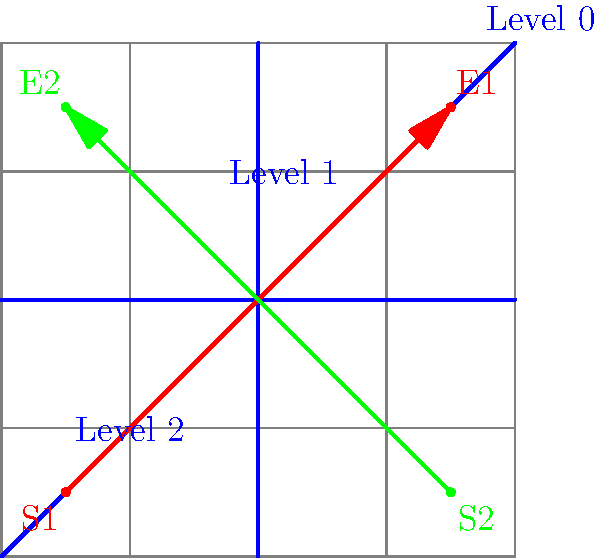In the context of implementing hierarchical pathfinding for a large open-world game map, as shown in the diagram, what is the primary advantage of using this approach over traditional A* pathfinding, and how would you calculate the heuristic cost between two points at different hierarchical levels? To understand the advantages of hierarchical pathfinding and calculate heuristics between different levels, let's break it down step-by-step:

1. Hierarchical Structure:
   The diagram shows a map divided into three levels (0, 1, and 2), with each level representing a different granularity of the game world.

2. Advantage over traditional A*:
   The primary advantage is improved performance for long-distance pathfinding. Instead of searching through every node in the game world, the algorithm can:
   a) First find a path at the highest level (Level 0)
   b) Then refine the path at lower levels (Level 1 and 2) only where necessary

3. Performance Improvement:
   This approach significantly reduces the number of nodes to be explored, especially for long paths across the map. For example, the red path (S1 to E1) can be quickly approximated at Level 0, then refined at lower levels.

4. Heuristic Calculation between Levels:
   To calculate the heuristic cost between points at different hierarchical levels:
   a) Project both points to the highest common level
   b) Calculate the heuristic at that level
   c) Add a penalty factor based on the level difference

5. Heuristic Formula:
   Let $h(a,b)$ be the heuristic between points $a$ and $b$, $l(x)$ be the level of point $x$, and $p$ be a penalty factor. The formula could be:

   $$ h(a,b) = h_{base}(a',b') + p \cdot |l(a) - l(b)| $$

   Where $a'$ and $b'$ are the projections of $a$ and $b$ to their highest common level, and $h_{base}$ is the base heuristic (e.g., Euclidean distance).

6. Implementation Consideration:
   When implementing this in a game engine, you would typically use abstractions like graphs or navigation meshes at each level, with connections between levels to allow for seamless path refinement.
Answer: Improved performance for long-distance pathfinding; heuristic = base_heuristic(projected_points) + penalty * level_difference 